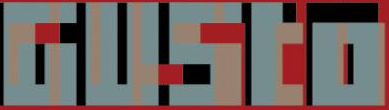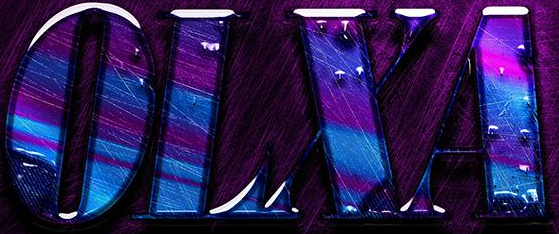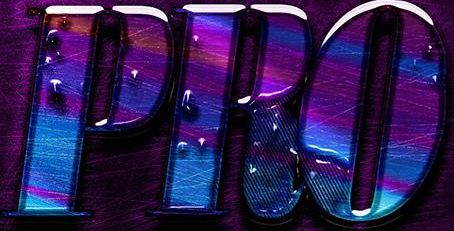What words can you see in these images in sequence, separated by a semicolon? GUSto; OLXA; PRO 